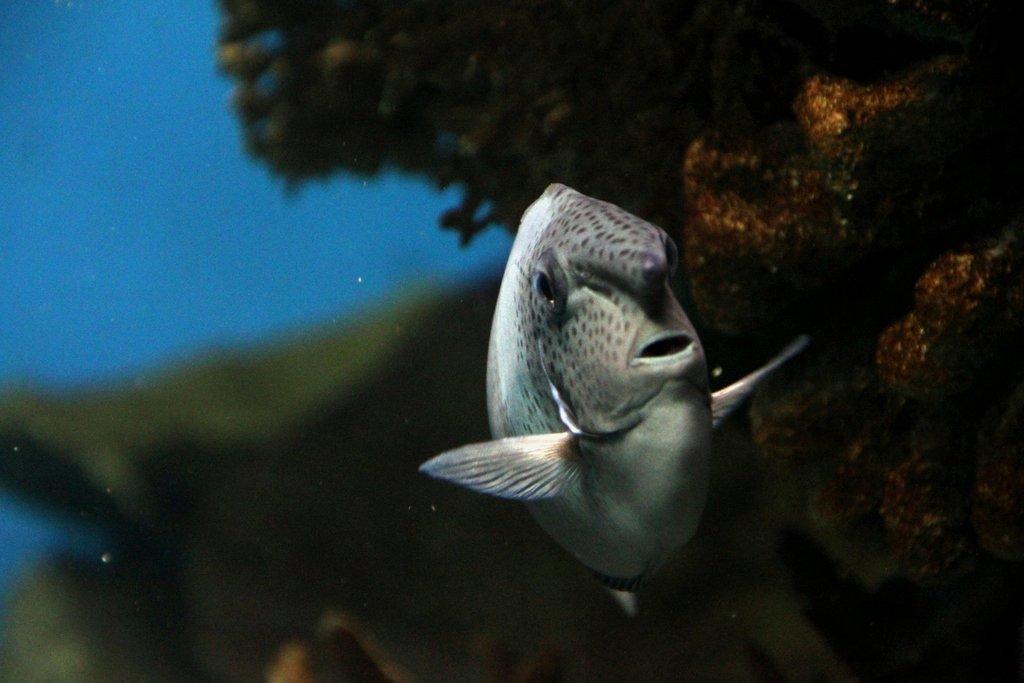How would you summarize this image in a sentence or two? There is a fish in water. 